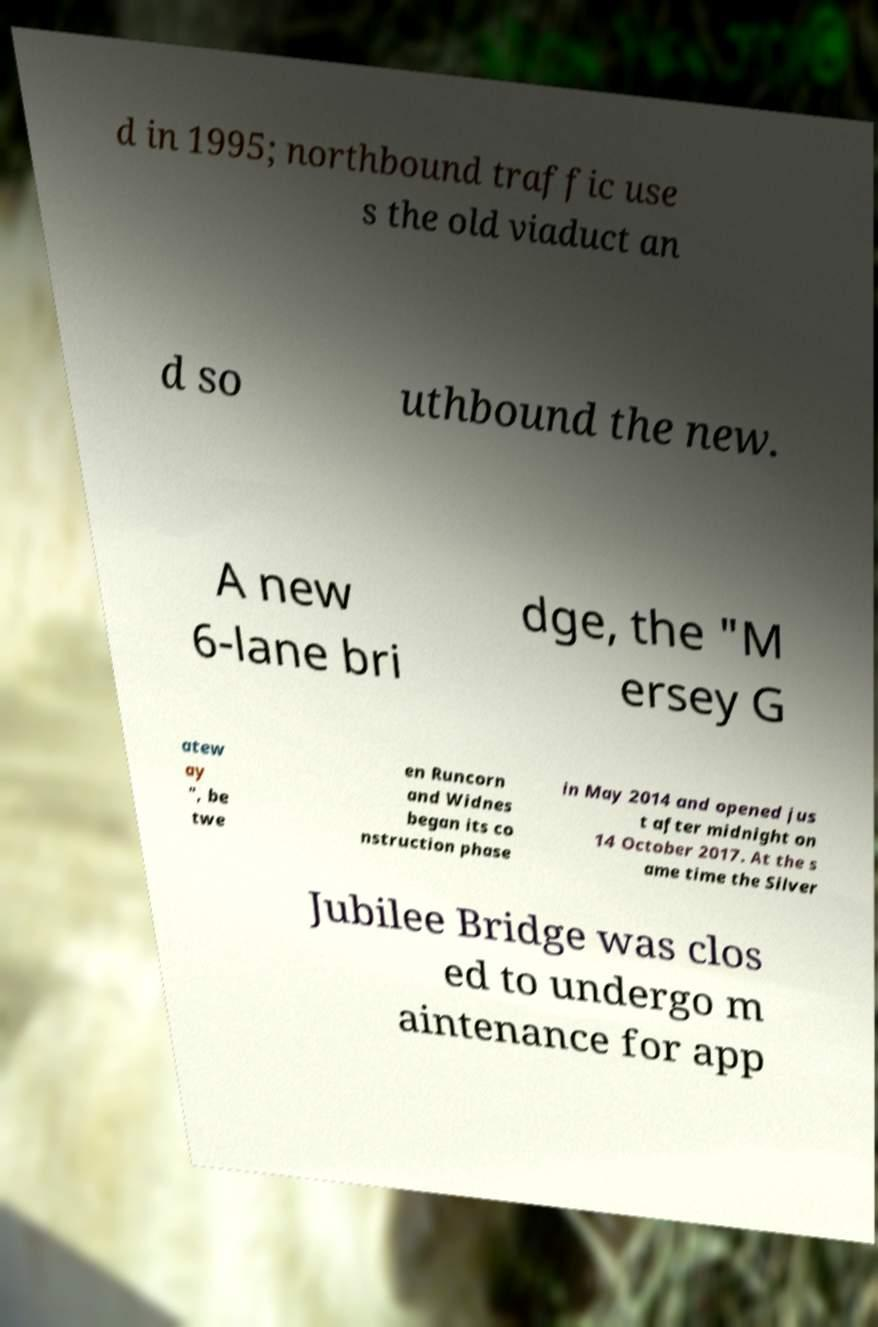There's text embedded in this image that I need extracted. Can you transcribe it verbatim? d in 1995; northbound traffic use s the old viaduct an d so uthbound the new. A new 6-lane bri dge, the "M ersey G atew ay ", be twe en Runcorn and Widnes began its co nstruction phase in May 2014 and opened jus t after midnight on 14 October 2017. At the s ame time the Silver Jubilee Bridge was clos ed to undergo m aintenance for app 